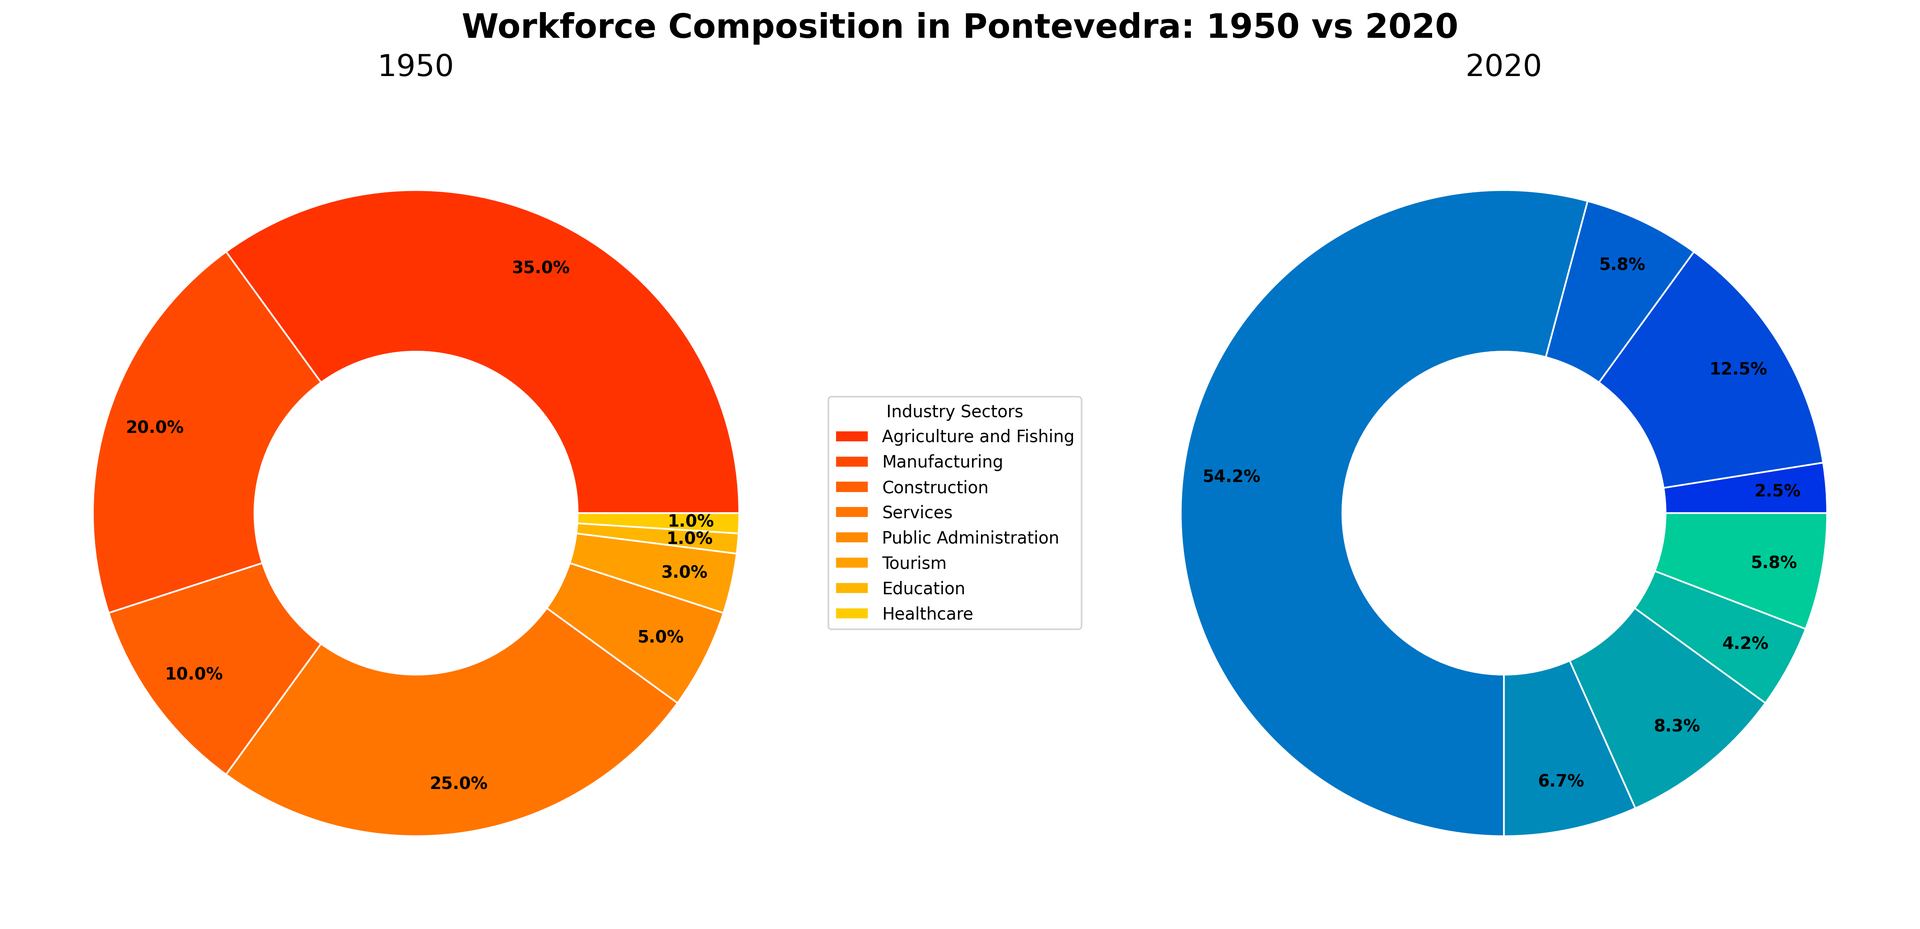Which industry sector experienced the most significant decline from 1950 to 2020? The Agriculture and Fishing sector had 35% of the workforce in 1950 and only 3% in 2020. The decline is calculated as 35% - 3% = 32%, which is the highest among all sectors.
Answer: Agriculture and Fishing Which industry sector accounted for the largest percentage of the workforce in 2020? The sector with the largest slice in the 2020 ring chart is marked as 65%, which corresponds to the Services sector.
Answer: Services What was the combined workforce percentage in Agriculture and Fishing, Manufacturing, and Construction in 1950? Sum the percentages for Agriculture and Fishing (35%), Manufacturing (20%), and Construction (10%). The total is 35% + 20% + 10% = 65%.
Answer: 65% Which sector saw the largest percentage increase from 1950 to 2020? By examining the difference between 1950 and 2020 for each sector, Tourism increased from 3% in 1950 to 10% in 2020. The increase is 10% - 3% = 7%, which is the largest.
Answer: Tourism Approximately how many sectors had a higher percentage share of the workforce in 2020 compared to 1950? Compare the values for each sector between the two years: Services (25% to 65%), Public Administration (5% to 8%), Tourism (3% to 10%), Education (1% to 5%), Healthcare (1% to 7%). Thus, five sectors increased.
Answer: Five Which sector saw a decline but remained in the same order of magnitude (within a 10% range) from 1950 to 2020? Both Manufacturing and Construction had declines but the change was within a 10% range. Manufacturing went from 20% to 15%, and Construction went from 10% to 7%.
Answer: Manufacturing/Construction What is the sum of the percentages for the Public Administration and Education sectors in 2020? Public Administration has 8% and Education has 5%. Summing these percentages gives 8% + 5% = 13%.
Answer: 13% How does the percentage of the workforce in Healthcare in 2020 compare to that in 1950? Healthcare had 1% in 1950 and 7% in 2020. To find the increase, calculate 7% - 1% = 6%.
Answer: Increase by 6% Which industry saw a relative increase, going from a single-digit percentage to double digits from 1950 to 2020? Tourism increased from 3% (a single-digit) to 10% (a double-digit) from 1950 to 2020.
Answer: Tourism What percentage of the workforce was involved in service-related sectors (Services and Tourism) in 2020? Combine the percentages of Services (65%) and Tourism (10%) in 2020. The total is 65% + 10% = 75%.
Answer: 75% 